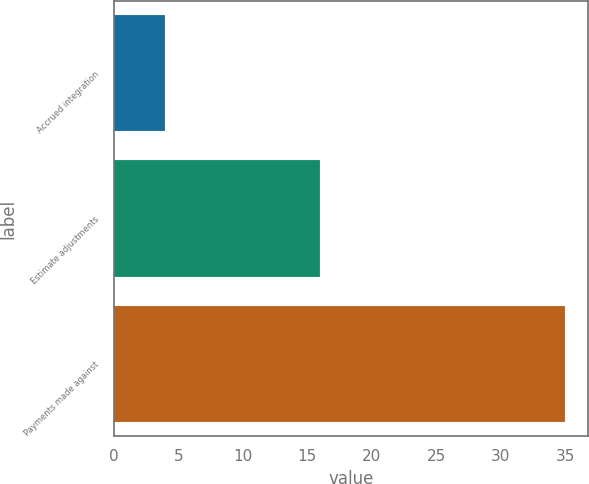Convert chart to OTSL. <chart><loc_0><loc_0><loc_500><loc_500><bar_chart><fcel>Accrued integration<fcel>Estimate adjustments<fcel>Payments made against<nl><fcel>4<fcel>16<fcel>35<nl></chart> 